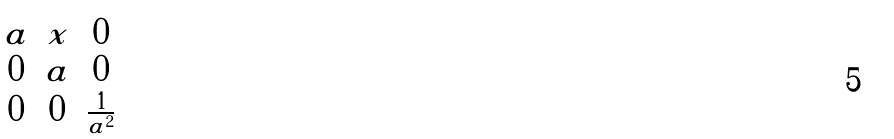Convert formula to latex. <formula><loc_0><loc_0><loc_500><loc_500>\begin{pmatrix} a & x & 0 \\ 0 & a & 0 \\ 0 & 0 & \frac { 1 } { a ^ { 2 } } \end{pmatrix}</formula> 